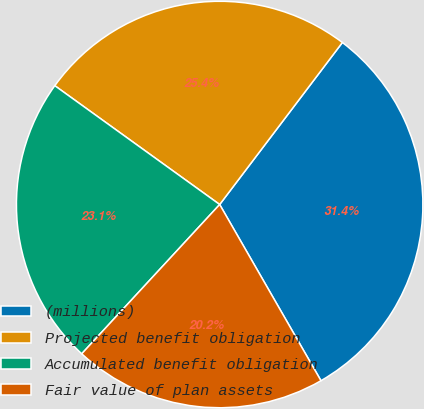Convert chart to OTSL. <chart><loc_0><loc_0><loc_500><loc_500><pie_chart><fcel>(millions)<fcel>Projected benefit obligation<fcel>Accumulated benefit obligation<fcel>Fair value of plan assets<nl><fcel>31.38%<fcel>25.38%<fcel>23.07%<fcel>20.18%<nl></chart> 